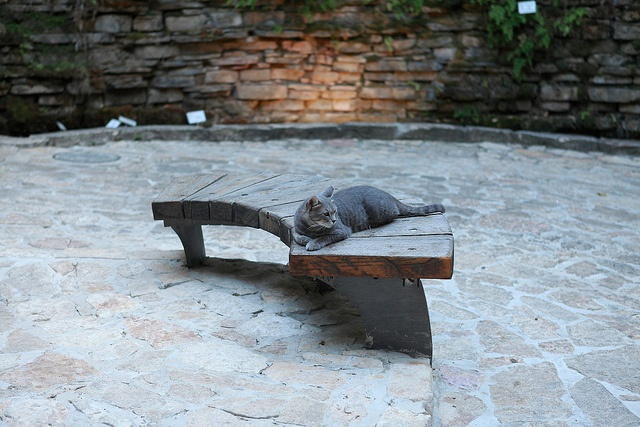Describe the objects in this image and their specific colors. I can see bench in black, darkgray, and gray tones and cat in black and gray tones in this image. 